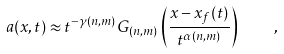Convert formula to latex. <formula><loc_0><loc_0><loc_500><loc_500>a ( x , t ) \approx t ^ { - \gamma ( n , m ) } G _ { ( n , m ) } \left ( \frac { x - x _ { f } ( t ) } { t ^ { \alpha ( n , m ) } } \right ) \quad ,</formula> 